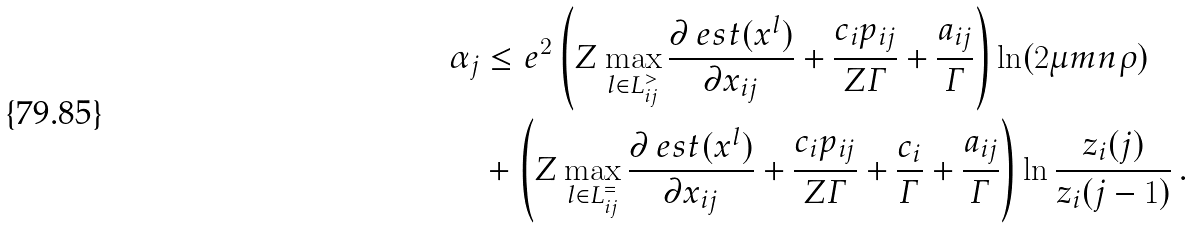Convert formula to latex. <formula><loc_0><loc_0><loc_500><loc_500>\alpha _ { j } & \leq e ^ { 2 } \left ( Z \max _ { l \in L _ { i j } ^ { > } } \frac { \partial \ e s t ( x ^ { l } ) } { \partial x _ { i j } } + \frac { c _ { i } p _ { i j } } { Z \varGamma } + \frac { a _ { i j } } { \varGamma } \right ) \ln ( 2 \mu m n \rho ) \\ & + \left ( Z \max _ { l \in L _ { i j } ^ { = } } \frac { \partial \ e s t ( x ^ { l } ) } { \partial x _ { i j } } + \frac { c _ { i } p _ { i j } } { Z \varGamma } + \frac { c _ { i } } { \varGamma } + \frac { a _ { i j } } { \varGamma } \right ) \ln \frac { z _ { i } ( j ) } { z _ { i } ( j - 1 ) } \, .</formula> 